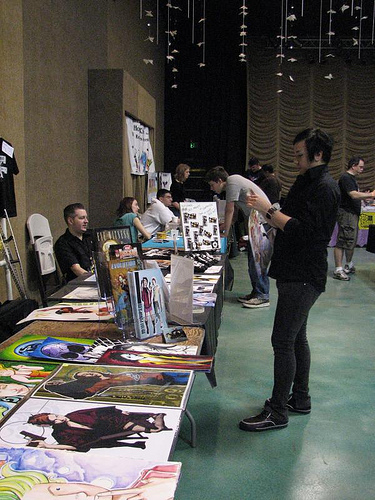<image>
Can you confirm if the guy is on the table? Yes. Looking at the image, I can see the guy is positioned on top of the table, with the table providing support. 